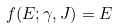<formula> <loc_0><loc_0><loc_500><loc_500>f ( E ; \gamma , J ) = E</formula> 